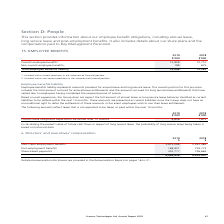According to Hansen Technologies's financial document, How much was the current employee benefits in 2019? According to the financial document, 13,859 (in thousands). The relevant text states: "Current employee benefits 1 13,859 12,710..." Also, What was the total employee benefits liability in 2018? According to the financial document, 13,385 (in thousands). The relevant text states: "Total employee benefits liability 14,048 13,385..." Also, What do employee benefits liability represent? amounts provided for annual leave and long service leave.. The document states: "Employee benefits liability represents amounts provided for annual leave and long service leave. The current portion for this provision includes the t..." Also, can you calculate: What was the percentage change in current employee benefits in 2018 and 2019? To answer this question, I need to perform calculations using the financial data. The calculation is: (13,859 - 12,710) / 12,710 , which equals 9.04 (percentage). This is based on the information: "Current employee benefits 1 13,859 12,710 Current employee benefits 1 13,859 12,710..." The key data points involved are: 12,710, 13,859. Also, can you calculate: What was the 2019 percentage change in total employee benefits liability? To answer this question, I need to perform calculations using the financial data. The calculation is: (14,048 - 13,385) / 13,385 , which equals 4.95 (percentage). This is based on the information: "Total employee benefits liability 14,048 13,385 Total employee benefits liability 14,048 13,385..." The key data points involved are: 13,385, 14,048. Also, can you calculate: What was the average non-current employee benefits for both years? To answer this question, I need to perform calculations using the financial data. The calculation is: (189 + 675) / 2 , which equals 432 (in thousands). This is based on the information: "Non-current employee benefits 2 189 675 Non-current employee benefits 2 189 675..." The key data points involved are: 189, 675. 